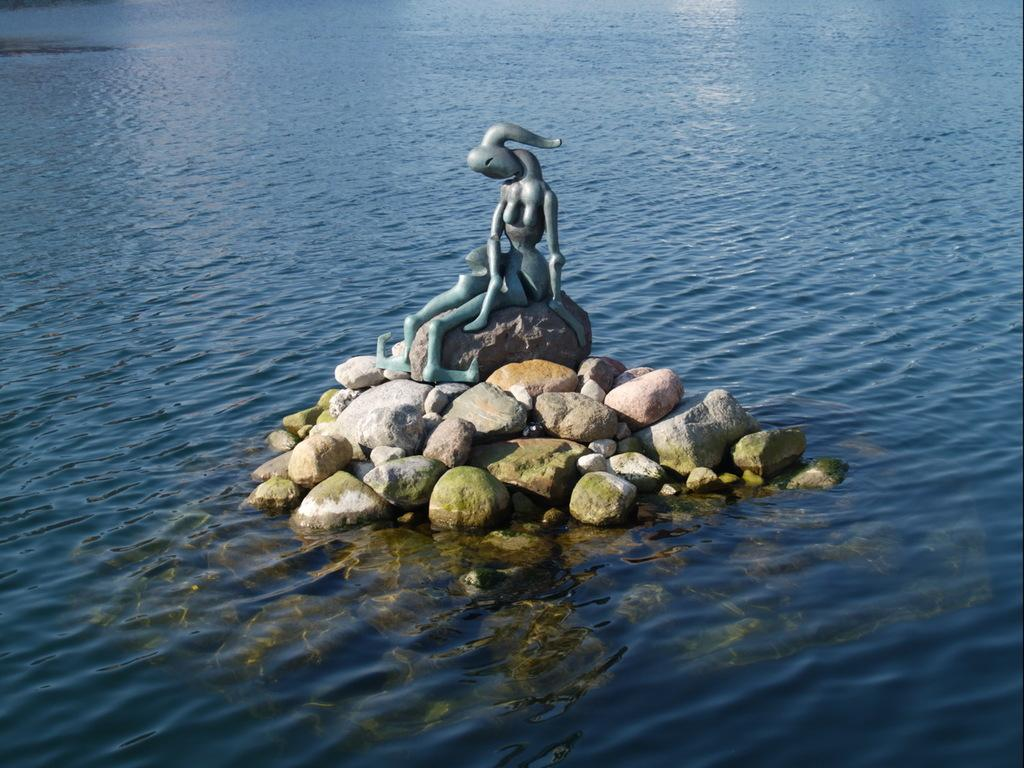What is the main subject of the image? There is a depiction of a person in the image. What is the person standing on? The person is on stones. What can be seen in the background of the image? There is water visible in the background of the image. What type of pancake is being served in the image? There is no pancake present in the image; it features a person standing on stones with water visible in the background. Can you hear any bells ringing in the image? There is no auditory information provided in the image, so it is impossible to determine if any bells are ringing. 